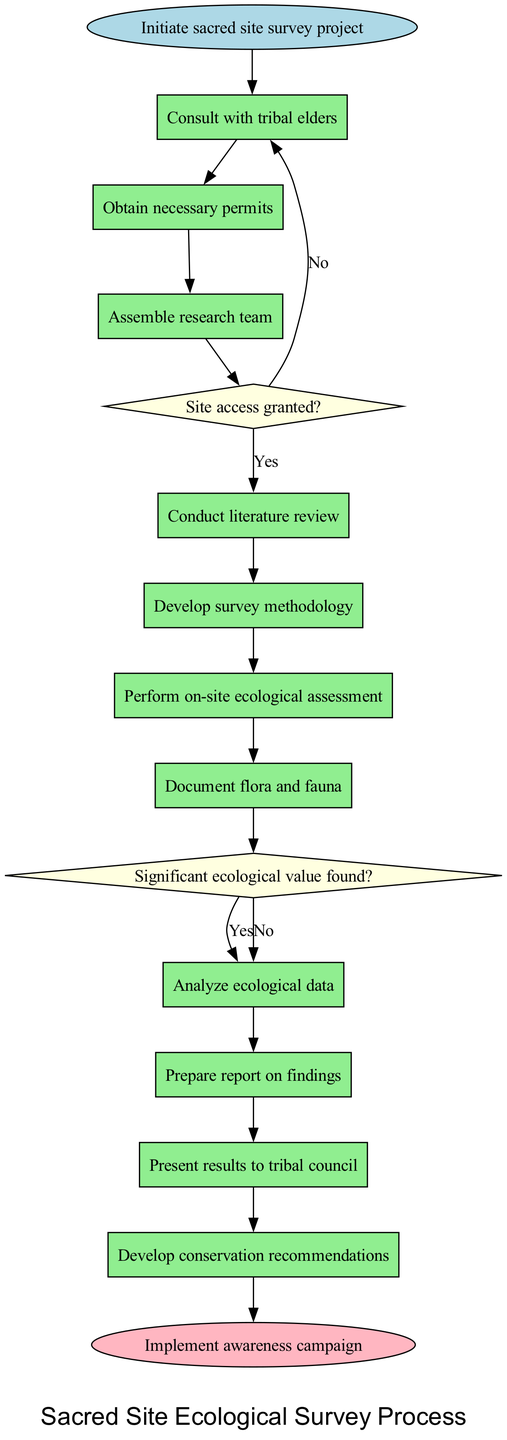What is the starting activity of the survey process? The diagram indicates that the process begins with the node labeled "Initiate sacred site survey project," which is the first activity listed.
Answer: Initiate sacred site survey project How many activities are there in total? By counting the activities listed in the diagram, we find there are ten distinct activities included in the survey process.
Answer: 10 What decision follows after "Assemble research team"? After "Assemble research team," the next node is a decision labeled "Site access granted?", which involves determining if access to the site is allowed.
Answer: Site access granted? What happens if "Significant ecological value found?" is answered with 'No'? If the answer to the decision "Significant ecological value found?" is 'No', the flow proceeds to document the findings, indicating no further actions are required for conservation prioritization.
Answer: Document findings How many decision nodes are present in the diagram? The diagram displays two decision nodes, indicating points in the process where choices influence subsequent actions.
Answer: 2 What is the last step of the survey process? The last step identified in the activity flow before reaching the end node is to "Develop conservation recommendations," which encapsulates key outcomes of the survey.
Answer: Develop conservation recommendations If the site access is not granted, what is the subsequent action? Following a 'No' answer to site access granted, the action would involve negotiating access or modifying the survey plan to find alternative ways to move forward with the project.
Answer: Negotiate access or modify plan What color represents the end node in the diagram? The end node is colored light pink, visually distinguishing it from other nodes in the process diagram.
Answer: Light pink What is the second activity listed in the survey process? The second activity in the enumerated process is "Obtain necessary permits," which follows the initiation of the project.
Answer: Obtain necessary permits What action immediately follows "Perform on-site ecological assessment"? The action that follows "Perform on-site ecological assessment" is "Document flora and fauna," indicating a direct reporting of what was observed during the assessment.
Answer: Document flora and fauna 